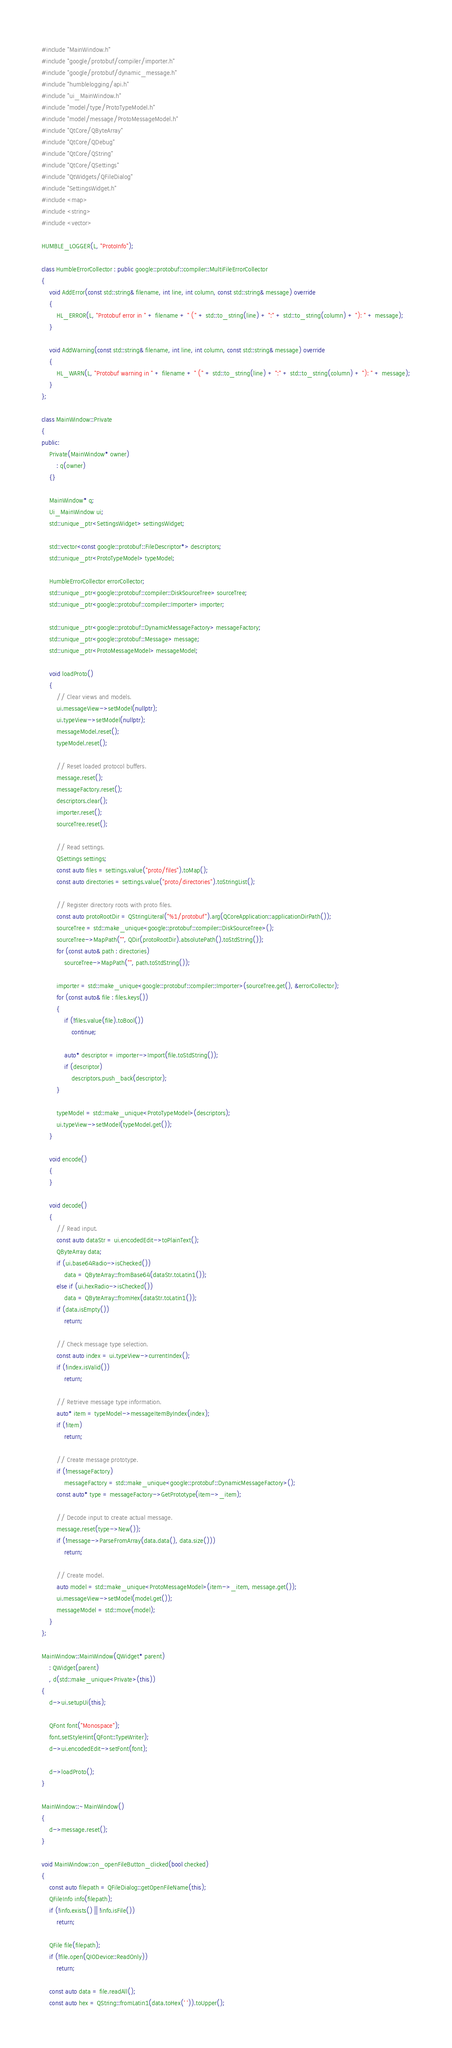<code> <loc_0><loc_0><loc_500><loc_500><_C++_>#include "MainWindow.h"
#include "google/protobuf/compiler/importer.h"
#include "google/protobuf/dynamic_message.h"
#include "humblelogging/api.h"
#include "ui_MainWindow.h"
#include "model/type/ProtoTypeModel.h"
#include "model/message/ProtoMessageModel.h"
#include "QtCore/QByteArray"
#include "QtCore/QDebug"
#include "QtCore/QString"
#include "QtCore/QSettings"
#include "QtWidgets/QFileDialog"
#include "SettingsWidget.h"
#include <map>
#include <string>
#include <vector>

HUMBLE_LOGGER(L, "ProtoInfo");

class HumbleErrorCollector : public google::protobuf::compiler::MultiFileErrorCollector
{
	void AddError(const std::string& filename, int line, int column, const std::string& message) override
	{
		HL_ERROR(L, "Protobuf error in " + filename + " (" + std::to_string(line) + ":" + std::to_string(column) + "): " + message);
	}

	void AddWarning(const std::string& filename, int line, int column, const std::string& message) override
	{
		HL_WARN(L, "Protobuf warning in " + filename + " (" + std::to_string(line) + ":" + std::to_string(column) + "): " + message);
	}
};

class MainWindow::Private
{
public:
	Private(MainWindow* owner)
		: q(owner)
	{}

	MainWindow* q;
	Ui_MainWindow ui;
	std::unique_ptr<SettingsWidget> settingsWidget;

	std::vector<const google::protobuf::FileDescriptor*> descriptors;
	std::unique_ptr<ProtoTypeModel> typeModel;

	HumbleErrorCollector errorCollector;
	std::unique_ptr<google::protobuf::compiler::DiskSourceTree> sourceTree;
	std::unique_ptr<google::protobuf::compiler::Importer> importer;

	std::unique_ptr<google::protobuf::DynamicMessageFactory> messageFactory;
	std::unique_ptr<google::protobuf::Message> message;
	std::unique_ptr<ProtoMessageModel> messageModel;

	void loadProto()
	{
		// Clear views and models.
		ui.messageView->setModel(nullptr);
		ui.typeView->setModel(nullptr);
		messageModel.reset();
		typeModel.reset();

		// Reset loaded protocol buffers.
		message.reset();
		messageFactory.reset();
		descriptors.clear();
		importer.reset();
		sourceTree.reset();

		// Read settings.
		QSettings settings;
		const auto files = settings.value("proto/files").toMap();
		const auto directories = settings.value("proto/directories").toStringList();

		// Register directory roots with proto files.
		const auto protoRootDir = QStringLiteral("%1/protobuf").arg(QCoreApplication::applicationDirPath());
		sourceTree = std::make_unique<google::protobuf::compiler::DiskSourceTree>();
		sourceTree->MapPath("", QDir(protoRootDir).absolutePath().toStdString());
		for (const auto& path : directories)
			sourceTree->MapPath("", path.toStdString());

		importer = std::make_unique<google::protobuf::compiler::Importer>(sourceTree.get(), &errorCollector);
		for (const auto& file : files.keys())
		{
			if (!files.value(file).toBool())
				continue;

			auto* descriptor = importer->Import(file.toStdString());
			if (descriptor)
				descriptors.push_back(descriptor);
		}

		typeModel = std::make_unique<ProtoTypeModel>(descriptors);
		ui.typeView->setModel(typeModel.get());
	}

	void encode()
	{
	}

	void decode()
	{
		// Read input.
		const auto dataStr = ui.encodedEdit->toPlainText();
		QByteArray data;
		if (ui.base64Radio->isChecked())
			data = QByteArray::fromBase64(dataStr.toLatin1());
		else if (ui.hexRadio->isChecked())
			data = QByteArray::fromHex(dataStr.toLatin1());
		if (data.isEmpty())
			return;

		// Check message type selection.
		const auto index = ui.typeView->currentIndex();
		if (!index.isValid())
			return;

		// Retrieve message type information.
		auto* item = typeModel->messageItemByIndex(index);
		if (!item)
			return;

		// Create message prototype.
		if (!messageFactory)
			messageFactory = std::make_unique<google::protobuf::DynamicMessageFactory>();
		const auto* type = messageFactory->GetPrototype(item->_item);

		// Decode input to create actual message.
		message.reset(type->New());
		if (!message->ParseFromArray(data.data(), data.size()))
			return;

		// Create model.
		auto model = std::make_unique<ProtoMessageModel>(item->_item, message.get());
		ui.messageView->setModel(model.get());
		messageModel = std::move(model);
	}
};

MainWindow::MainWindow(QWidget* parent)
	: QWidget(parent)
	, d(std::make_unique<Private>(this))
{
	d->ui.setupUi(this);

	QFont font("Monospace");
	font.setStyleHint(QFont::TypeWriter);
	d->ui.encodedEdit->setFont(font);

	d->loadProto();
}

MainWindow::~MainWindow()
{
	d->message.reset();
}

void MainWindow::on_openFileButton_clicked(bool checked)
{
	const auto filepath = QFileDialog::getOpenFileName(this);
	QFileInfo info(filepath);
	if (!info.exists() || !info.isFile())
		return;

	QFile file(filepath);
	if (!file.open(QIODevice::ReadOnly))
		return;

	const auto data = file.readAll();
	const auto hex = QString::fromLatin1(data.toHex(' ')).toUpper();
</code> 